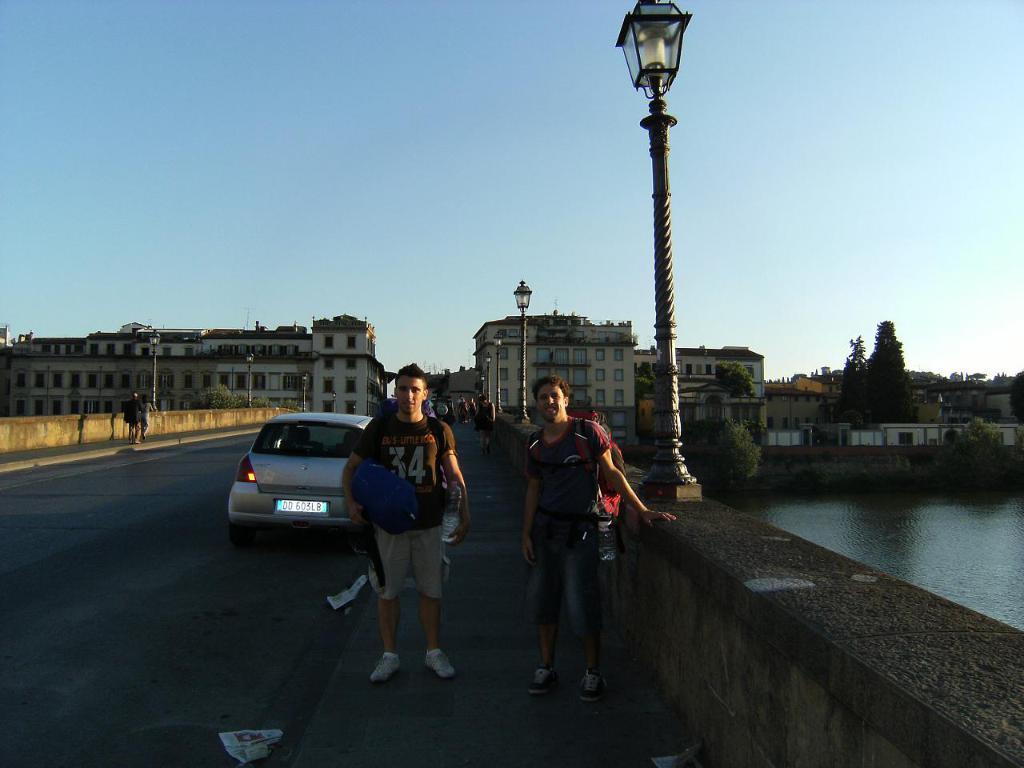In one or two sentences, can you explain what this image depicts? In this image in the center there are persons standing. In the background there is a car moving on the road and there are persons walking, there are poles, buildings and trees and there is water on the right side and in the front on the road there is a paper. 